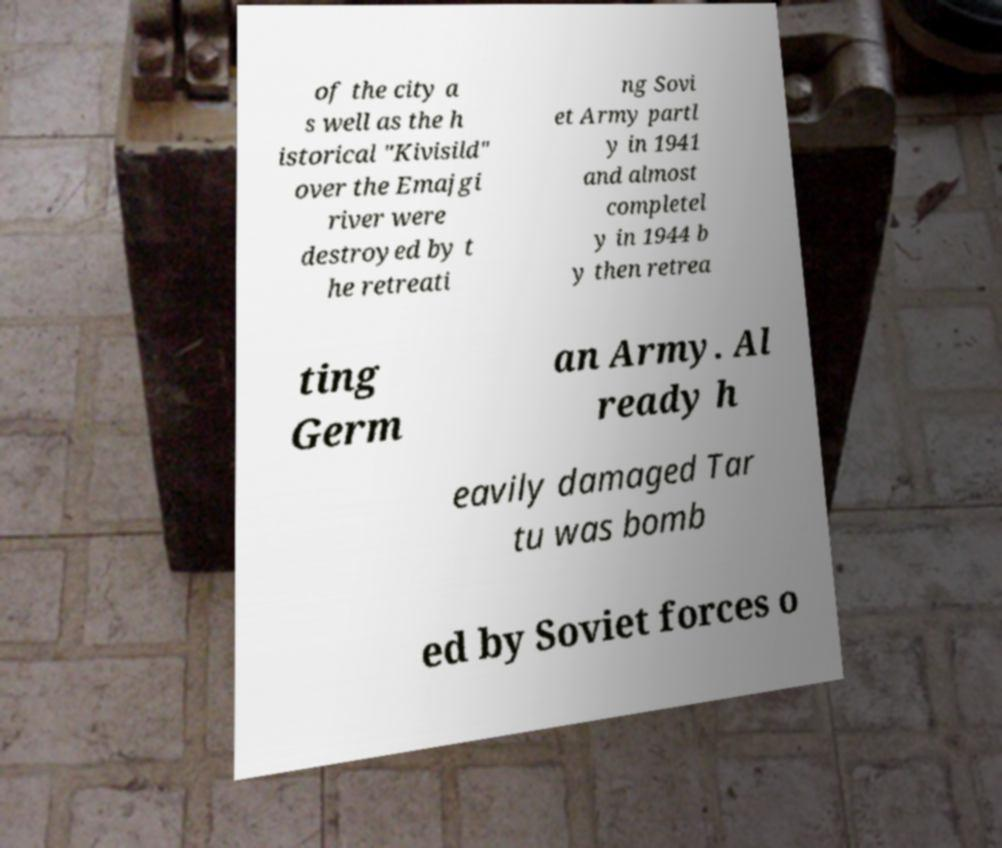Could you extract and type out the text from this image? of the city a s well as the h istorical "Kivisild" over the Emajgi river were destroyed by t he retreati ng Sovi et Army partl y in 1941 and almost completel y in 1944 b y then retrea ting Germ an Army. Al ready h eavily damaged Tar tu was bomb ed by Soviet forces o 